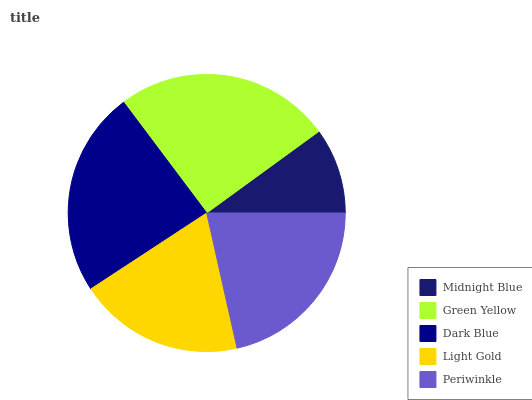Is Midnight Blue the minimum?
Answer yes or no. Yes. Is Green Yellow the maximum?
Answer yes or no. Yes. Is Dark Blue the minimum?
Answer yes or no. No. Is Dark Blue the maximum?
Answer yes or no. No. Is Green Yellow greater than Dark Blue?
Answer yes or no. Yes. Is Dark Blue less than Green Yellow?
Answer yes or no. Yes. Is Dark Blue greater than Green Yellow?
Answer yes or no. No. Is Green Yellow less than Dark Blue?
Answer yes or no. No. Is Periwinkle the high median?
Answer yes or no. Yes. Is Periwinkle the low median?
Answer yes or no. Yes. Is Dark Blue the high median?
Answer yes or no. No. Is Light Gold the low median?
Answer yes or no. No. 